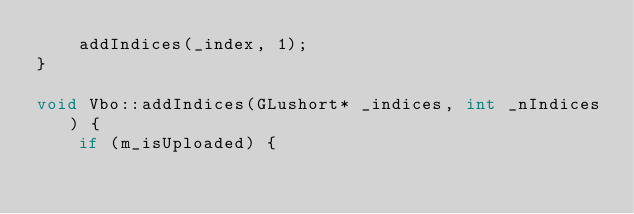Convert code to text. <code><loc_0><loc_0><loc_500><loc_500><_C++_>    addIndices(_index, 1);
}

void Vbo::addIndices(GLushort* _indices, int _nIndices) {
    if (m_isUploaded) {</code> 